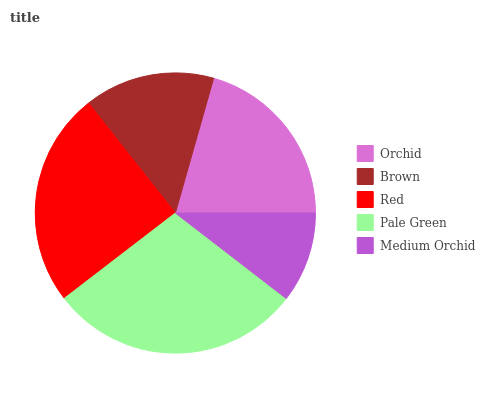Is Medium Orchid the minimum?
Answer yes or no. Yes. Is Pale Green the maximum?
Answer yes or no. Yes. Is Brown the minimum?
Answer yes or no. No. Is Brown the maximum?
Answer yes or no. No. Is Orchid greater than Brown?
Answer yes or no. Yes. Is Brown less than Orchid?
Answer yes or no. Yes. Is Brown greater than Orchid?
Answer yes or no. No. Is Orchid less than Brown?
Answer yes or no. No. Is Orchid the high median?
Answer yes or no. Yes. Is Orchid the low median?
Answer yes or no. Yes. Is Brown the high median?
Answer yes or no. No. Is Pale Green the low median?
Answer yes or no. No. 